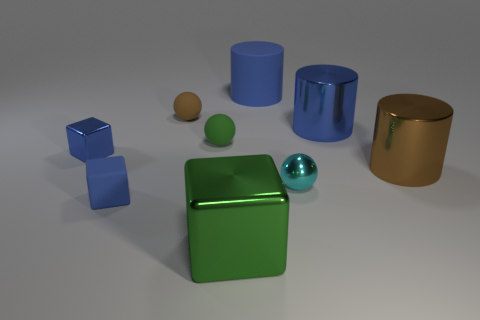There is a matte thing that is the same color as the tiny rubber cube; what is its size?
Your answer should be very brief. Large. There is a big shiny object that is in front of the big brown shiny object; what number of balls are right of it?
Make the answer very short. 1. What number of other things are made of the same material as the large brown cylinder?
Give a very brief answer. 4. Does the tiny object to the left of the small blue matte cube have the same material as the brown object that is behind the tiny green object?
Ensure brevity in your answer.  No. Does the large block have the same material as the tiny green object to the right of the tiny blue rubber thing?
Provide a succinct answer. No. There is a metal cube right of the brown thing that is on the left side of the rubber object that is on the right side of the green block; what is its color?
Make the answer very short. Green. There is a blue rubber object that is the same size as the blue shiny cube; what is its shape?
Give a very brief answer. Cube. Does the cylinder in front of the tiny blue metallic thing have the same size as the shiny cube that is behind the tiny blue matte thing?
Your answer should be very brief. No. There is a green object that is in front of the cyan object; what size is it?
Your answer should be compact. Large. There is a object that is the same color as the large cube; what is it made of?
Your answer should be compact. Rubber. 